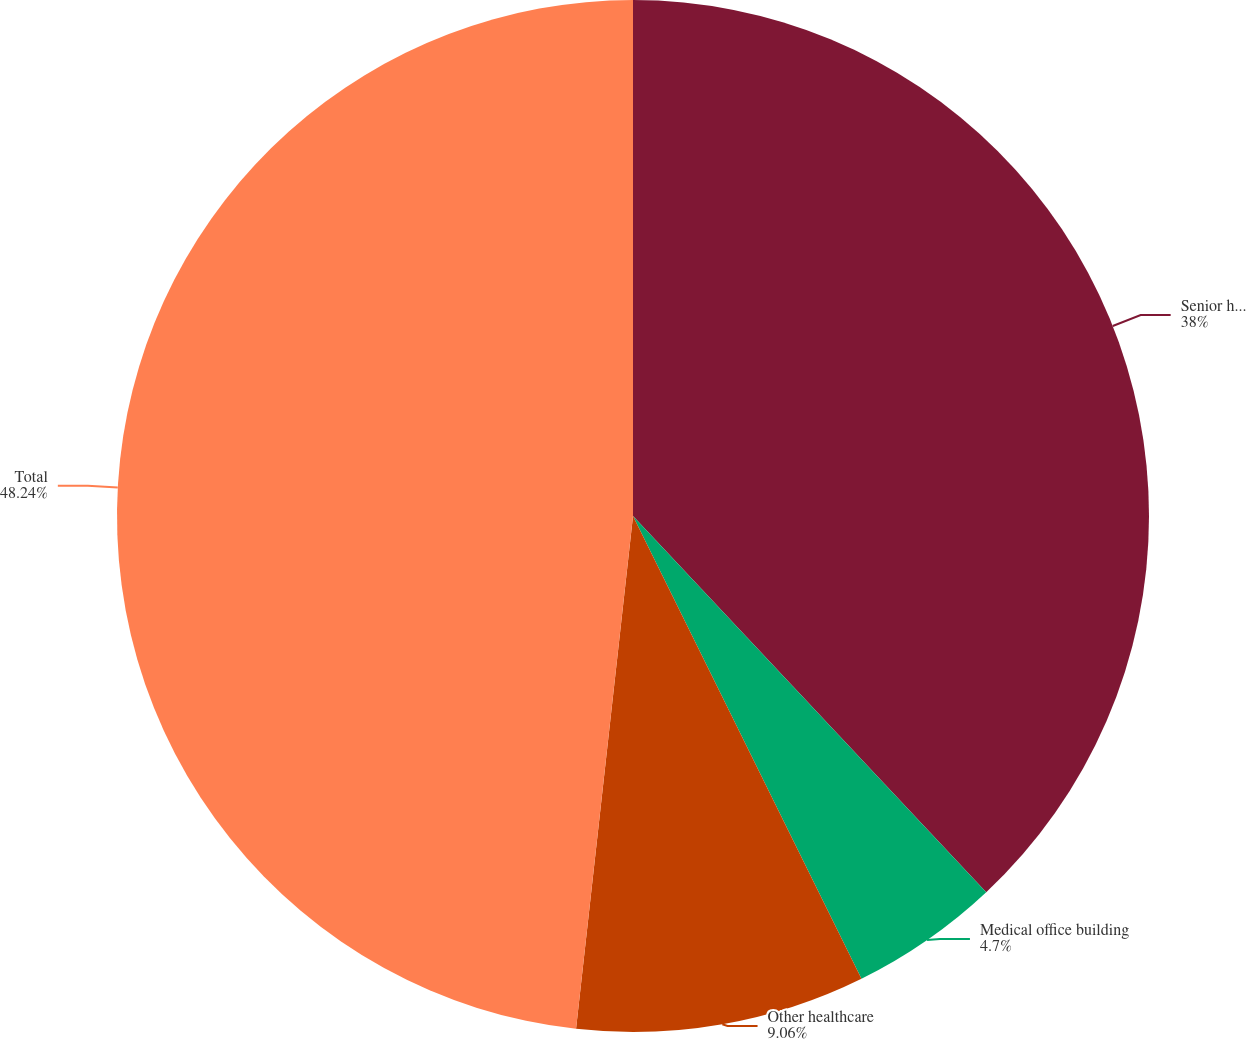Convert chart. <chart><loc_0><loc_0><loc_500><loc_500><pie_chart><fcel>Senior housing<fcel>Medical office building<fcel>Other healthcare<fcel>Total<nl><fcel>38.0%<fcel>4.7%<fcel>9.06%<fcel>48.24%<nl></chart> 